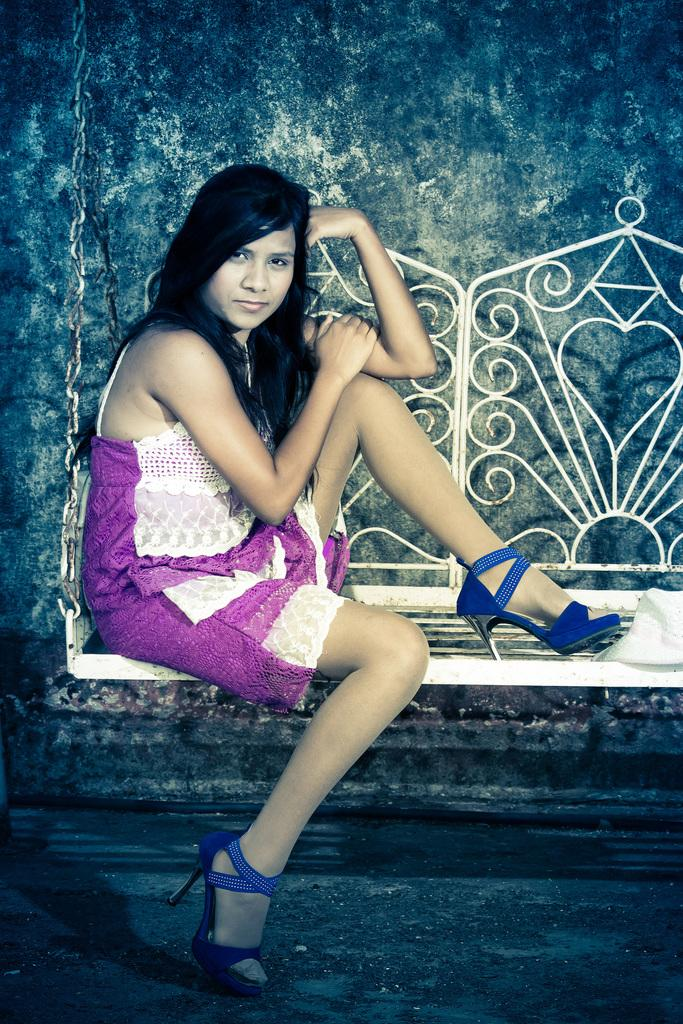Who is the main subject in the picture? There is a woman in the picture. What is the woman doing in the image? The woman is sitting on a swing. What is the woman wearing in the image? The woman is wearing a white and pink color dress. What can be seen in the background of the picture? There is a wall in the background of the picture. What type of ray can be seen swimming in the background of the image? There is no ray present in the image; it features a woman sitting on a swing with a wall in the background. Is there a bathtub visible in the image? No, there is no bathtub present in the image. 